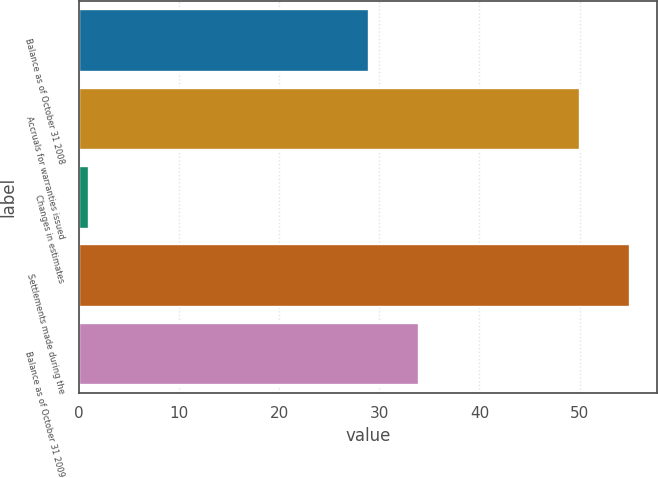<chart> <loc_0><loc_0><loc_500><loc_500><bar_chart><fcel>Balance as of October 31 2008<fcel>Accruals for warranties issued<fcel>Changes in estimates<fcel>Settlements made during the<fcel>Balance as of October 31 2009<nl><fcel>29<fcel>50<fcel>1<fcel>55<fcel>34<nl></chart> 